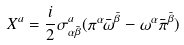<formula> <loc_0><loc_0><loc_500><loc_500>X ^ { a } = \frac { i } { 2 } \sigma ^ { a } _ { \alpha { \bar { \beta } } } ( \pi ^ { \alpha } { \bar { \omega } } ^ { \bar { \beta } } - \omega ^ { \alpha } { \bar { \pi } } ^ { \bar { \beta } } )</formula> 